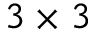<formula> <loc_0><loc_0><loc_500><loc_500>3 \times 3</formula> 